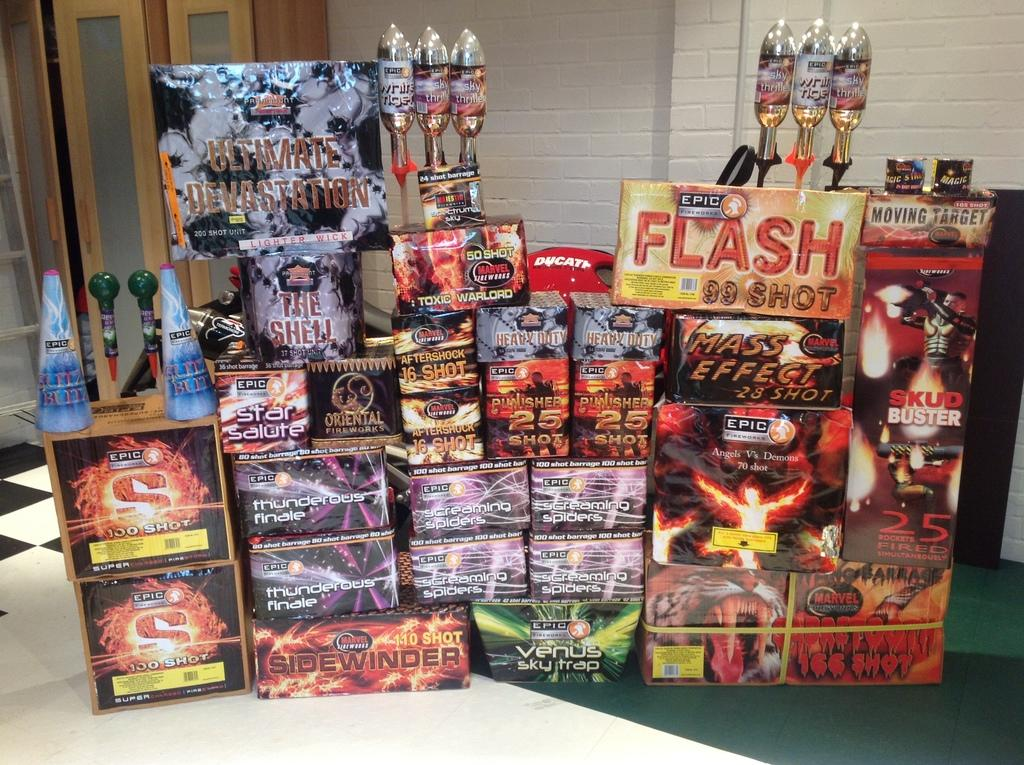Provide a one-sentence caption for the provided image. A display of stacked products advertises a product called Ultimate Devastation. 